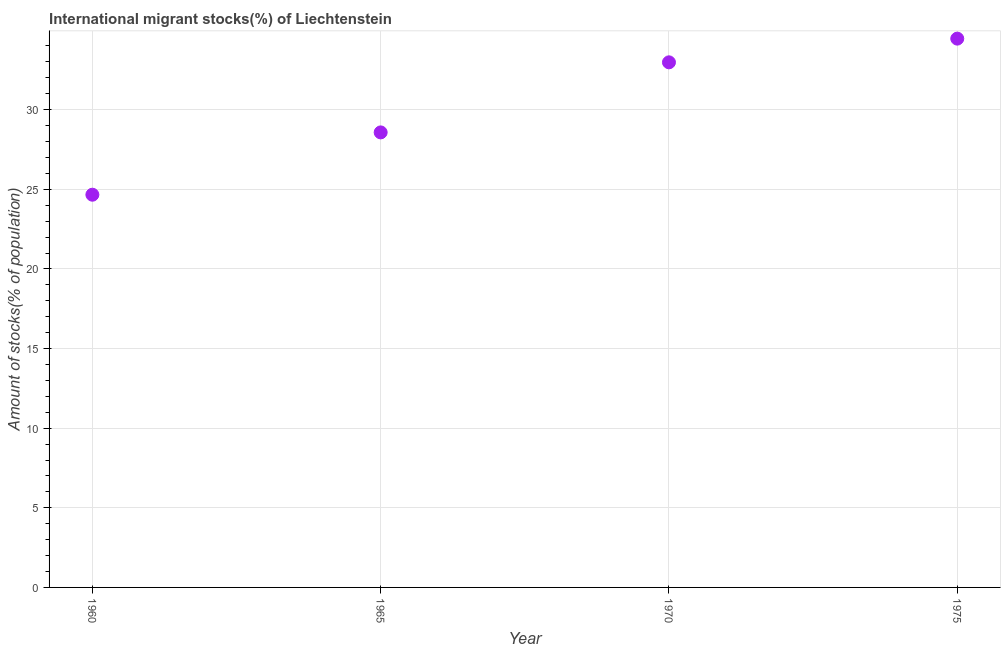What is the number of international migrant stocks in 1960?
Your answer should be compact. 24.66. Across all years, what is the maximum number of international migrant stocks?
Give a very brief answer. 34.46. Across all years, what is the minimum number of international migrant stocks?
Keep it short and to the point. 24.66. In which year was the number of international migrant stocks maximum?
Provide a short and direct response. 1975. In which year was the number of international migrant stocks minimum?
Ensure brevity in your answer.  1960. What is the sum of the number of international migrant stocks?
Give a very brief answer. 120.67. What is the difference between the number of international migrant stocks in 1960 and 1975?
Provide a succinct answer. -9.8. What is the average number of international migrant stocks per year?
Your response must be concise. 30.17. What is the median number of international migrant stocks?
Your answer should be very brief. 30.77. In how many years, is the number of international migrant stocks greater than 19 %?
Offer a very short reply. 4. Do a majority of the years between 1960 and 1965 (inclusive) have number of international migrant stocks greater than 6 %?
Ensure brevity in your answer.  Yes. What is the ratio of the number of international migrant stocks in 1970 to that in 1975?
Offer a terse response. 0.96. Is the number of international migrant stocks in 1965 less than that in 1970?
Your answer should be very brief. Yes. Is the difference between the number of international migrant stocks in 1960 and 1965 greater than the difference between any two years?
Your answer should be very brief. No. What is the difference between the highest and the second highest number of international migrant stocks?
Give a very brief answer. 1.49. What is the difference between the highest and the lowest number of international migrant stocks?
Give a very brief answer. 9.8. Does the number of international migrant stocks monotonically increase over the years?
Your response must be concise. Yes. How many years are there in the graph?
Your answer should be very brief. 4. What is the difference between two consecutive major ticks on the Y-axis?
Keep it short and to the point. 5. Are the values on the major ticks of Y-axis written in scientific E-notation?
Make the answer very short. No. Does the graph contain grids?
Provide a short and direct response. Yes. What is the title of the graph?
Keep it short and to the point. International migrant stocks(%) of Liechtenstein. What is the label or title of the Y-axis?
Ensure brevity in your answer.  Amount of stocks(% of population). What is the Amount of stocks(% of population) in 1960?
Give a very brief answer. 24.66. What is the Amount of stocks(% of population) in 1965?
Your response must be concise. 28.57. What is the Amount of stocks(% of population) in 1970?
Your answer should be very brief. 32.97. What is the Amount of stocks(% of population) in 1975?
Your answer should be very brief. 34.46. What is the difference between the Amount of stocks(% of population) in 1960 and 1965?
Ensure brevity in your answer.  -3.91. What is the difference between the Amount of stocks(% of population) in 1960 and 1970?
Your response must be concise. -8.31. What is the difference between the Amount of stocks(% of population) in 1960 and 1975?
Your response must be concise. -9.8. What is the difference between the Amount of stocks(% of population) in 1965 and 1970?
Provide a succinct answer. -4.4. What is the difference between the Amount of stocks(% of population) in 1965 and 1975?
Ensure brevity in your answer.  -5.89. What is the difference between the Amount of stocks(% of population) in 1970 and 1975?
Your response must be concise. -1.49. What is the ratio of the Amount of stocks(% of population) in 1960 to that in 1965?
Ensure brevity in your answer.  0.86. What is the ratio of the Amount of stocks(% of population) in 1960 to that in 1970?
Make the answer very short. 0.75. What is the ratio of the Amount of stocks(% of population) in 1960 to that in 1975?
Offer a terse response. 0.72. What is the ratio of the Amount of stocks(% of population) in 1965 to that in 1970?
Give a very brief answer. 0.87. What is the ratio of the Amount of stocks(% of population) in 1965 to that in 1975?
Offer a terse response. 0.83. 